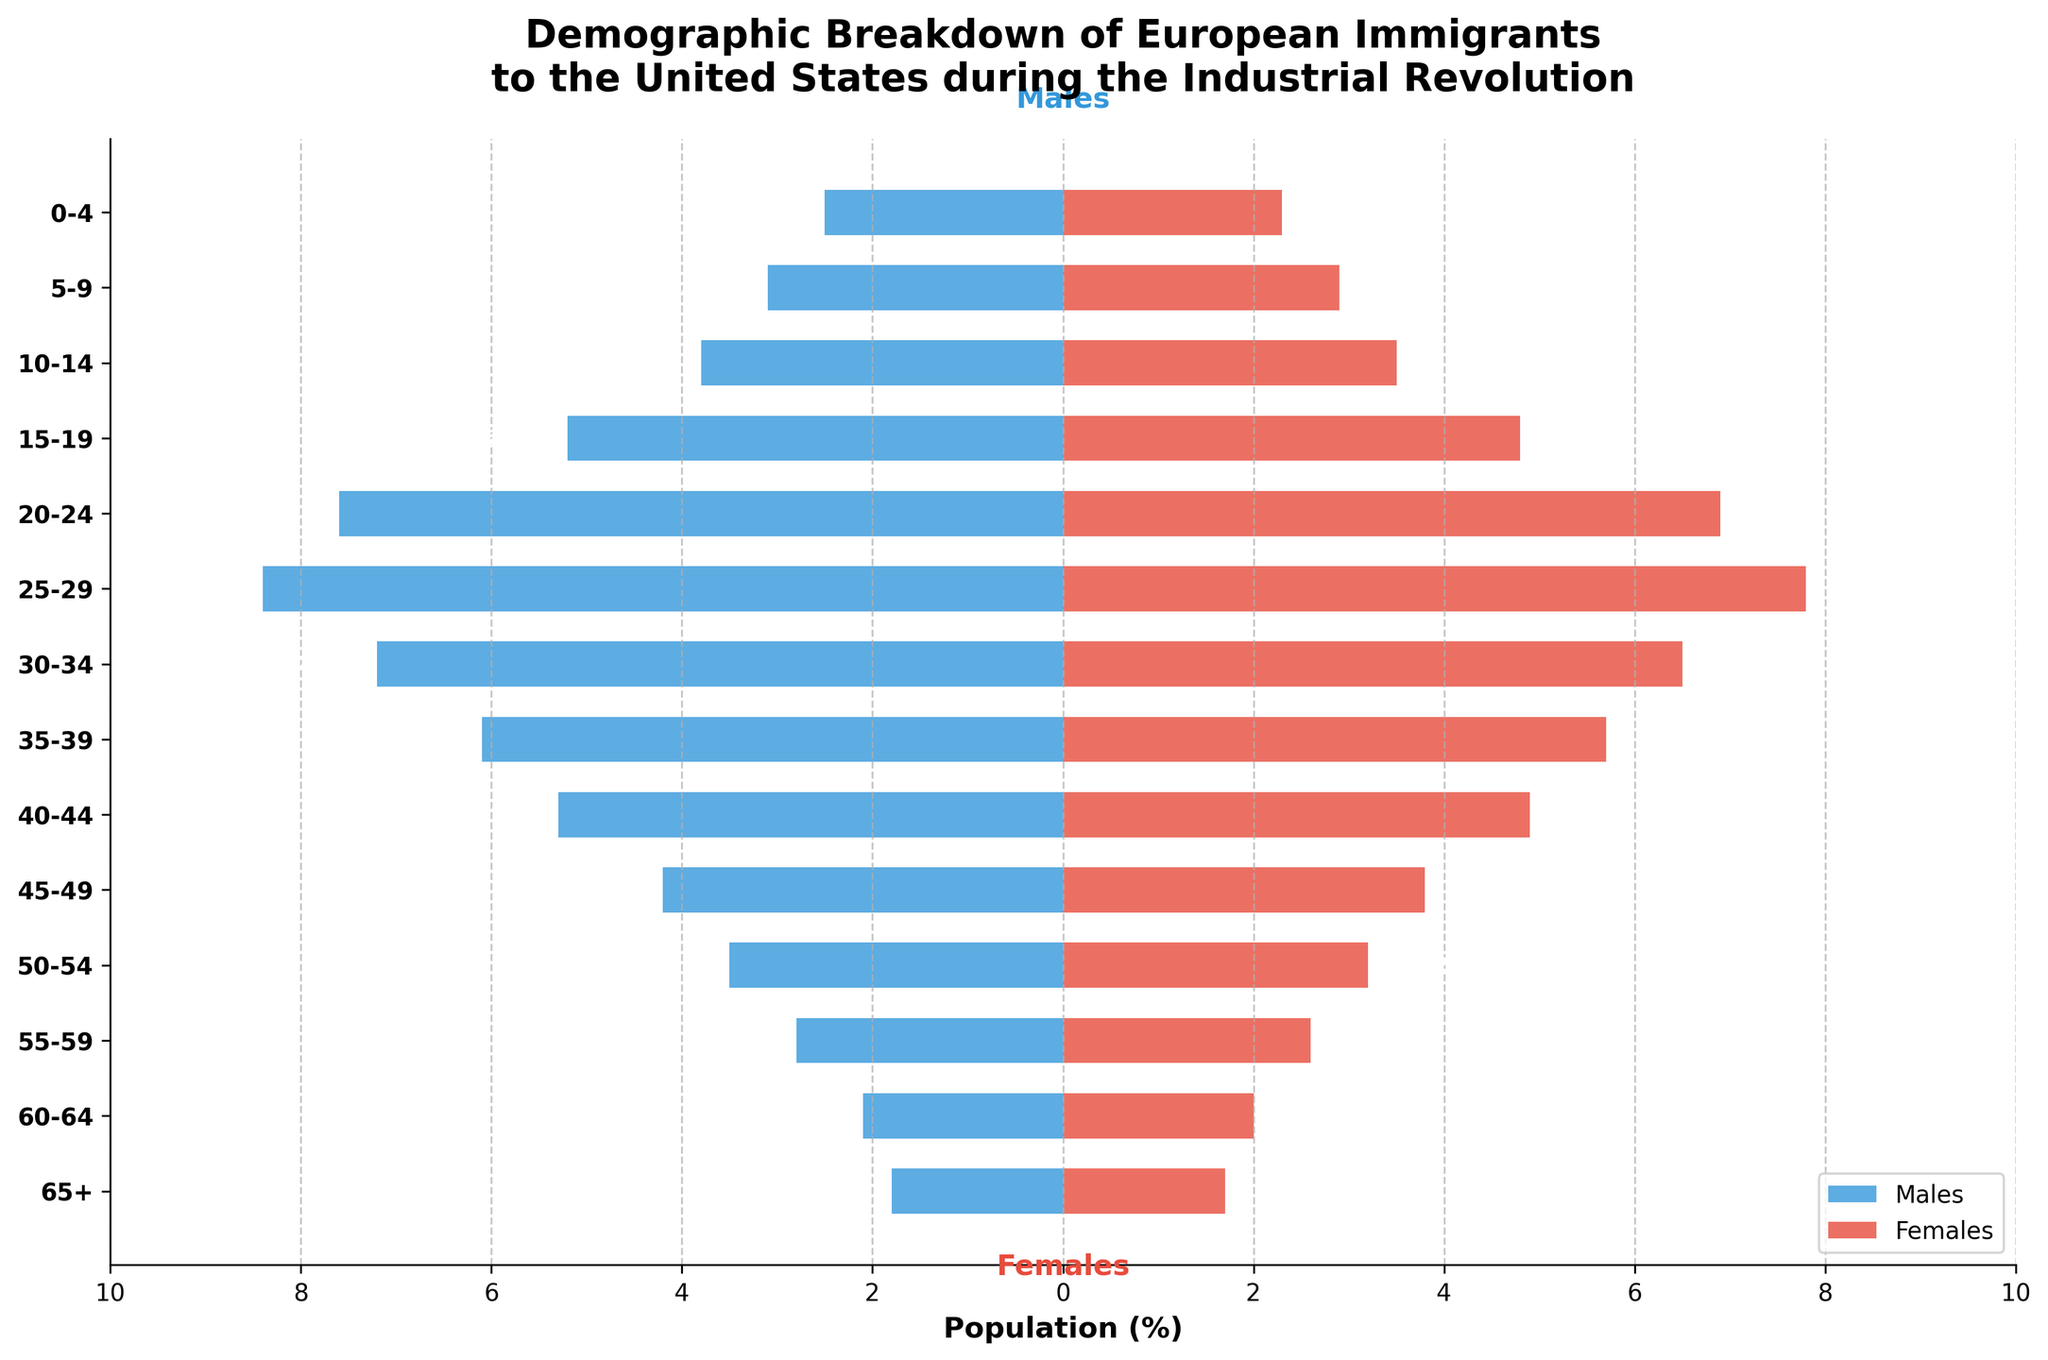What's the title of the figure? The title is usually displayed prominently at the top of the figure. In this case, the title, "Demographic Breakdown of European Immigrants to the United States during the Industrial Revolution," gives us a clear context of the data being visualized.
Answer: Demographic Breakdown of European Immigrants to the United States during the Industrial Revolution Which age group has the highest percentage of males? By observing the length of the horizontal bars on the left side of the plot, we see that the age group "25-29" has the longest bar, representing the highest percentage.
Answer: 25-29 How does the percentage of females aged 20-24 compare to that of males aged 20-24? The length of the horizontal bars can be compared directly. The female bar ends at 6.9%, while the male bar extends to -7.6%.
Answer: The percentage of females is less than that of males What is the total percentage of the population for the age group 0-4? Since we need to add both male and female percentages, the values are 2.5% for males and 2.3% for females. The sum is 2.5 + 2.3 = 4.8%.
Answer: 4.8% Which gender has a higher total percentage in the age group 35-39? For the age group 35-39, the percentage for males is 6.1% and for females is 5.7%. By comparing these values directly, males have a higher percentage.
Answer: Males What's the trend in population percentage for older age groups (60-64 and 65+)? Observing the bars, both male and female percentages decrease in these older age groups compared to younger ones. Specifically, the 60-64 male percentage is 2.1% and the 65+ is 1.8%; for females, it's 2.0% for 60-64 and 1.7% for 65+.
Answer: Decreasing How much greater is the percentage of males in the age group 15-19 compared to the age group 55-59? Here, calculate the difference between the percentages for these age groups: 5.2% (15-19) - 2.8% (55-59) = 2.4%.
Answer: 2.4% What can you infer about the working-age population (20-64) in this demographic? Summarizing percentages for both males and females in this range provides insight. For males (20-24, 25-29, 30-34, 35-39, 40-44, 45-49, 50-54, 55-59, 60-64): 7.6+8.4+7.2+6.1+5.3+4.2+3.5+2.8+2.1 = 47.2. For females in the same range: 6.9+7.8+6.5+5.7+4.9+3.8+3.2+2.6+2.0 = 43.4. Both males and females within the working-age group represent significant portions, indicating immigration for labor during the Industrial Revolution.
Answer: Significant working-age population Which age group shows the smallest difference in percentage between males and females? By calculating the difference for each age group, the group 65+ shows a minimal difference: 1.8% (males) - 1.7% (females) = 0.1%.
Answer: 65+ What do the colors of the bars represent in the figure? The bars use two colors to differentiate genders: blue for males and red for females, allowing easy visual distinction between demographics. This is inferred from the legend and the annotations.
Answer: Blue for males, red for females 